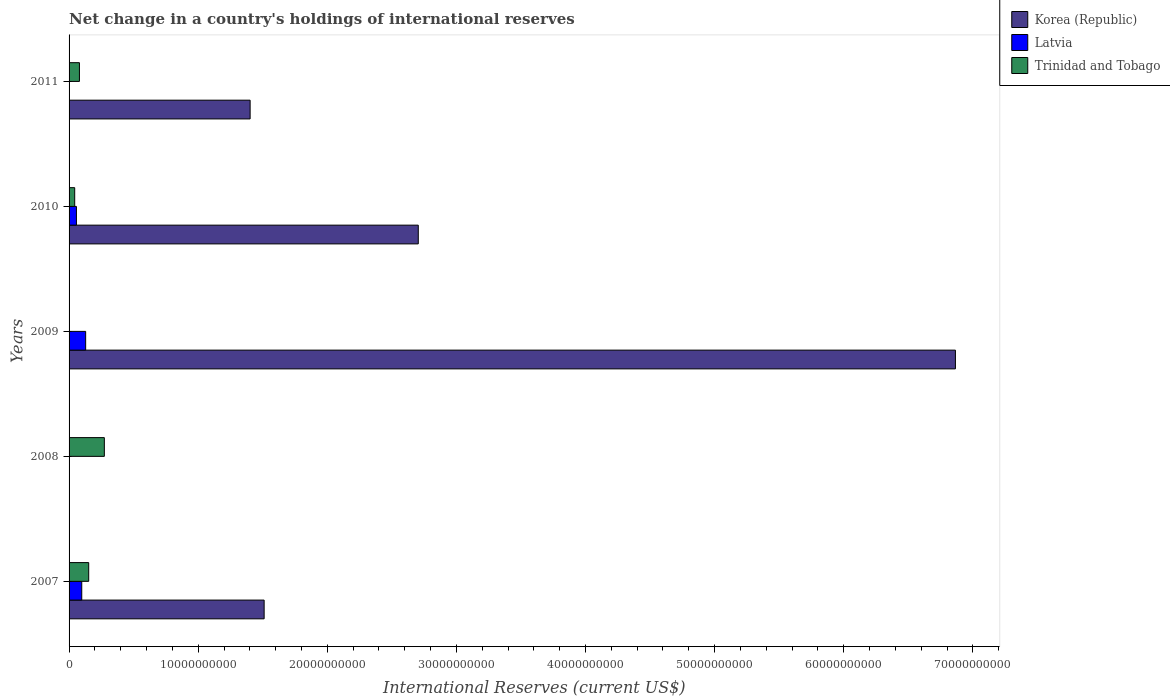How many different coloured bars are there?
Make the answer very short. 3. Are the number of bars per tick equal to the number of legend labels?
Offer a terse response. No. How many bars are there on the 2nd tick from the bottom?
Provide a short and direct response. 1. What is the label of the 3rd group of bars from the top?
Keep it short and to the point. 2009. What is the international reserves in Latvia in 2010?
Make the answer very short. 5.70e+08. Across all years, what is the maximum international reserves in Trinidad and Tobago?
Give a very brief answer. 2.73e+09. What is the total international reserves in Latvia in the graph?
Keep it short and to the point. 2.84e+09. What is the difference between the international reserves in Korea (Republic) in 2007 and that in 2010?
Your answer should be compact. -1.19e+1. What is the difference between the international reserves in Trinidad and Tobago in 2010 and the international reserves in Latvia in 2011?
Provide a short and direct response. 4.36e+08. What is the average international reserves in Trinidad and Tobago per year?
Offer a terse response. 1.10e+09. In the year 2010, what is the difference between the international reserves in Trinidad and Tobago and international reserves in Latvia?
Your answer should be compact. -1.34e+08. What is the ratio of the international reserves in Korea (Republic) in 2007 to that in 2009?
Keep it short and to the point. 0.22. Is the international reserves in Trinidad and Tobago in 2008 less than that in 2010?
Keep it short and to the point. No. What is the difference between the highest and the second highest international reserves in Korea (Republic)?
Keep it short and to the point. 4.16e+1. What is the difference between the highest and the lowest international reserves in Latvia?
Offer a very short reply. 1.28e+09. Is the sum of the international reserves in Trinidad and Tobago in 2007 and 2011 greater than the maximum international reserves in Latvia across all years?
Your answer should be very brief. Yes. Is it the case that in every year, the sum of the international reserves in Latvia and international reserves in Trinidad and Tobago is greater than the international reserves in Korea (Republic)?
Make the answer very short. No. What is the difference between two consecutive major ticks on the X-axis?
Your answer should be compact. 1.00e+1. Does the graph contain any zero values?
Keep it short and to the point. Yes. Does the graph contain grids?
Offer a very short reply. No. How are the legend labels stacked?
Your answer should be compact. Vertical. What is the title of the graph?
Make the answer very short. Net change in a country's holdings of international reserves. Does "Yemen, Rep." appear as one of the legend labels in the graph?
Your response must be concise. No. What is the label or title of the X-axis?
Make the answer very short. International Reserves (current US$). What is the label or title of the Y-axis?
Provide a succinct answer. Years. What is the International Reserves (current US$) in Korea (Republic) in 2007?
Ensure brevity in your answer.  1.51e+1. What is the International Reserves (current US$) of Latvia in 2007?
Your response must be concise. 9.82e+08. What is the International Reserves (current US$) in Trinidad and Tobago in 2007?
Your answer should be very brief. 1.52e+09. What is the International Reserves (current US$) in Korea (Republic) in 2008?
Your response must be concise. 0. What is the International Reserves (current US$) of Trinidad and Tobago in 2008?
Ensure brevity in your answer.  2.73e+09. What is the International Reserves (current US$) of Korea (Republic) in 2009?
Offer a terse response. 6.87e+1. What is the International Reserves (current US$) in Latvia in 2009?
Ensure brevity in your answer.  1.28e+09. What is the International Reserves (current US$) of Korea (Republic) in 2010?
Keep it short and to the point. 2.70e+1. What is the International Reserves (current US$) of Latvia in 2010?
Make the answer very short. 5.70e+08. What is the International Reserves (current US$) of Trinidad and Tobago in 2010?
Provide a short and direct response. 4.36e+08. What is the International Reserves (current US$) in Korea (Republic) in 2011?
Your response must be concise. 1.40e+1. What is the International Reserves (current US$) in Latvia in 2011?
Make the answer very short. 0. What is the International Reserves (current US$) of Trinidad and Tobago in 2011?
Give a very brief answer. 8.03e+08. Across all years, what is the maximum International Reserves (current US$) in Korea (Republic)?
Offer a terse response. 6.87e+1. Across all years, what is the maximum International Reserves (current US$) in Latvia?
Offer a terse response. 1.28e+09. Across all years, what is the maximum International Reserves (current US$) in Trinidad and Tobago?
Your response must be concise. 2.73e+09. What is the total International Reserves (current US$) of Korea (Republic) in the graph?
Your answer should be very brief. 1.25e+11. What is the total International Reserves (current US$) of Latvia in the graph?
Your answer should be very brief. 2.84e+09. What is the total International Reserves (current US$) of Trinidad and Tobago in the graph?
Offer a very short reply. 5.49e+09. What is the difference between the International Reserves (current US$) of Trinidad and Tobago in 2007 and that in 2008?
Make the answer very short. -1.21e+09. What is the difference between the International Reserves (current US$) of Korea (Republic) in 2007 and that in 2009?
Give a very brief answer. -5.35e+1. What is the difference between the International Reserves (current US$) of Latvia in 2007 and that in 2009?
Keep it short and to the point. -3.03e+08. What is the difference between the International Reserves (current US$) in Korea (Republic) in 2007 and that in 2010?
Keep it short and to the point. -1.19e+1. What is the difference between the International Reserves (current US$) in Latvia in 2007 and that in 2010?
Provide a short and direct response. 4.12e+08. What is the difference between the International Reserves (current US$) in Trinidad and Tobago in 2007 and that in 2010?
Offer a very short reply. 1.08e+09. What is the difference between the International Reserves (current US$) in Korea (Republic) in 2007 and that in 2011?
Give a very brief answer. 1.09e+09. What is the difference between the International Reserves (current US$) of Trinidad and Tobago in 2007 and that in 2011?
Your answer should be very brief. 7.18e+08. What is the difference between the International Reserves (current US$) in Trinidad and Tobago in 2008 and that in 2010?
Your answer should be very brief. 2.30e+09. What is the difference between the International Reserves (current US$) in Trinidad and Tobago in 2008 and that in 2011?
Ensure brevity in your answer.  1.93e+09. What is the difference between the International Reserves (current US$) of Korea (Republic) in 2009 and that in 2010?
Keep it short and to the point. 4.16e+1. What is the difference between the International Reserves (current US$) of Latvia in 2009 and that in 2010?
Offer a very short reply. 7.15e+08. What is the difference between the International Reserves (current US$) of Korea (Republic) in 2009 and that in 2011?
Keep it short and to the point. 5.46e+1. What is the difference between the International Reserves (current US$) in Korea (Republic) in 2010 and that in 2011?
Provide a succinct answer. 1.30e+1. What is the difference between the International Reserves (current US$) of Trinidad and Tobago in 2010 and that in 2011?
Keep it short and to the point. -3.67e+08. What is the difference between the International Reserves (current US$) of Korea (Republic) in 2007 and the International Reserves (current US$) of Trinidad and Tobago in 2008?
Provide a succinct answer. 1.24e+1. What is the difference between the International Reserves (current US$) of Latvia in 2007 and the International Reserves (current US$) of Trinidad and Tobago in 2008?
Your answer should be compact. -1.75e+09. What is the difference between the International Reserves (current US$) of Korea (Republic) in 2007 and the International Reserves (current US$) of Latvia in 2009?
Ensure brevity in your answer.  1.38e+1. What is the difference between the International Reserves (current US$) in Korea (Republic) in 2007 and the International Reserves (current US$) in Latvia in 2010?
Offer a terse response. 1.45e+1. What is the difference between the International Reserves (current US$) in Korea (Republic) in 2007 and the International Reserves (current US$) in Trinidad and Tobago in 2010?
Make the answer very short. 1.47e+1. What is the difference between the International Reserves (current US$) in Latvia in 2007 and the International Reserves (current US$) in Trinidad and Tobago in 2010?
Offer a very short reply. 5.46e+08. What is the difference between the International Reserves (current US$) of Korea (Republic) in 2007 and the International Reserves (current US$) of Trinidad and Tobago in 2011?
Keep it short and to the point. 1.43e+1. What is the difference between the International Reserves (current US$) of Latvia in 2007 and the International Reserves (current US$) of Trinidad and Tobago in 2011?
Give a very brief answer. 1.79e+08. What is the difference between the International Reserves (current US$) of Korea (Republic) in 2009 and the International Reserves (current US$) of Latvia in 2010?
Your response must be concise. 6.81e+1. What is the difference between the International Reserves (current US$) of Korea (Republic) in 2009 and the International Reserves (current US$) of Trinidad and Tobago in 2010?
Offer a very short reply. 6.82e+1. What is the difference between the International Reserves (current US$) in Latvia in 2009 and the International Reserves (current US$) in Trinidad and Tobago in 2010?
Your answer should be very brief. 8.49e+08. What is the difference between the International Reserves (current US$) of Korea (Republic) in 2009 and the International Reserves (current US$) of Trinidad and Tobago in 2011?
Keep it short and to the point. 6.78e+1. What is the difference between the International Reserves (current US$) of Latvia in 2009 and the International Reserves (current US$) of Trinidad and Tobago in 2011?
Offer a very short reply. 4.82e+08. What is the difference between the International Reserves (current US$) of Korea (Republic) in 2010 and the International Reserves (current US$) of Trinidad and Tobago in 2011?
Offer a very short reply. 2.62e+1. What is the difference between the International Reserves (current US$) in Latvia in 2010 and the International Reserves (current US$) in Trinidad and Tobago in 2011?
Give a very brief answer. -2.33e+08. What is the average International Reserves (current US$) of Korea (Republic) per year?
Provide a short and direct response. 2.50e+1. What is the average International Reserves (current US$) in Latvia per year?
Offer a terse response. 5.67e+08. What is the average International Reserves (current US$) of Trinidad and Tobago per year?
Provide a succinct answer. 1.10e+09. In the year 2007, what is the difference between the International Reserves (current US$) of Korea (Republic) and International Reserves (current US$) of Latvia?
Your response must be concise. 1.41e+1. In the year 2007, what is the difference between the International Reserves (current US$) in Korea (Republic) and International Reserves (current US$) in Trinidad and Tobago?
Provide a short and direct response. 1.36e+1. In the year 2007, what is the difference between the International Reserves (current US$) in Latvia and International Reserves (current US$) in Trinidad and Tobago?
Your answer should be compact. -5.38e+08. In the year 2009, what is the difference between the International Reserves (current US$) in Korea (Republic) and International Reserves (current US$) in Latvia?
Ensure brevity in your answer.  6.74e+1. In the year 2010, what is the difference between the International Reserves (current US$) in Korea (Republic) and International Reserves (current US$) in Latvia?
Your answer should be very brief. 2.65e+1. In the year 2010, what is the difference between the International Reserves (current US$) in Korea (Republic) and International Reserves (current US$) in Trinidad and Tobago?
Provide a succinct answer. 2.66e+1. In the year 2010, what is the difference between the International Reserves (current US$) in Latvia and International Reserves (current US$) in Trinidad and Tobago?
Keep it short and to the point. 1.34e+08. In the year 2011, what is the difference between the International Reserves (current US$) of Korea (Republic) and International Reserves (current US$) of Trinidad and Tobago?
Provide a short and direct response. 1.32e+1. What is the ratio of the International Reserves (current US$) in Trinidad and Tobago in 2007 to that in 2008?
Keep it short and to the point. 0.56. What is the ratio of the International Reserves (current US$) in Korea (Republic) in 2007 to that in 2009?
Give a very brief answer. 0.22. What is the ratio of the International Reserves (current US$) of Latvia in 2007 to that in 2009?
Your answer should be compact. 0.76. What is the ratio of the International Reserves (current US$) of Korea (Republic) in 2007 to that in 2010?
Provide a succinct answer. 0.56. What is the ratio of the International Reserves (current US$) of Latvia in 2007 to that in 2010?
Provide a short and direct response. 1.72. What is the ratio of the International Reserves (current US$) of Trinidad and Tobago in 2007 to that in 2010?
Offer a terse response. 3.49. What is the ratio of the International Reserves (current US$) of Korea (Republic) in 2007 to that in 2011?
Offer a terse response. 1.08. What is the ratio of the International Reserves (current US$) in Trinidad and Tobago in 2007 to that in 2011?
Your answer should be compact. 1.89. What is the ratio of the International Reserves (current US$) of Trinidad and Tobago in 2008 to that in 2010?
Your answer should be very brief. 6.26. What is the ratio of the International Reserves (current US$) in Trinidad and Tobago in 2008 to that in 2011?
Provide a short and direct response. 3.4. What is the ratio of the International Reserves (current US$) in Korea (Republic) in 2009 to that in 2010?
Keep it short and to the point. 2.54. What is the ratio of the International Reserves (current US$) in Latvia in 2009 to that in 2010?
Your answer should be compact. 2.25. What is the ratio of the International Reserves (current US$) in Korea (Republic) in 2009 to that in 2011?
Keep it short and to the point. 4.9. What is the ratio of the International Reserves (current US$) in Korea (Republic) in 2010 to that in 2011?
Provide a short and direct response. 1.93. What is the ratio of the International Reserves (current US$) in Trinidad and Tobago in 2010 to that in 2011?
Provide a short and direct response. 0.54. What is the difference between the highest and the second highest International Reserves (current US$) of Korea (Republic)?
Make the answer very short. 4.16e+1. What is the difference between the highest and the second highest International Reserves (current US$) of Latvia?
Give a very brief answer. 3.03e+08. What is the difference between the highest and the second highest International Reserves (current US$) in Trinidad and Tobago?
Offer a very short reply. 1.21e+09. What is the difference between the highest and the lowest International Reserves (current US$) of Korea (Republic)?
Offer a terse response. 6.87e+1. What is the difference between the highest and the lowest International Reserves (current US$) of Latvia?
Provide a short and direct response. 1.28e+09. What is the difference between the highest and the lowest International Reserves (current US$) of Trinidad and Tobago?
Offer a very short reply. 2.73e+09. 